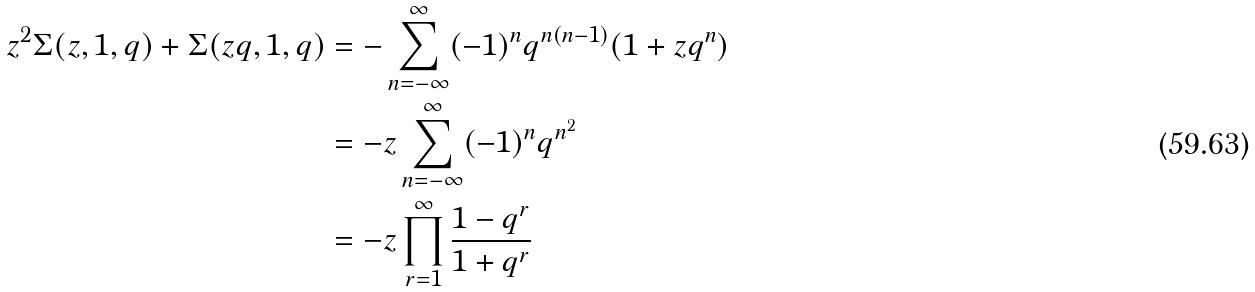<formula> <loc_0><loc_0><loc_500><loc_500>z ^ { 2 } \Sigma ( z , 1 , q ) + \Sigma ( z q , 1 , q ) & = - \sum _ { n = - \infty } ^ { \infty } ( - 1 ) ^ { n } q ^ { n ( n - 1 ) } ( 1 + z q ^ { n } ) \\ & = - z \sum _ { n = - \infty } ^ { \infty } ( - 1 ) ^ { n } q ^ { n ^ { 2 } } \\ & = - z \prod _ { r = 1 } ^ { \infty } \frac { 1 - q ^ { r } } { 1 + q ^ { r } } \\</formula> 